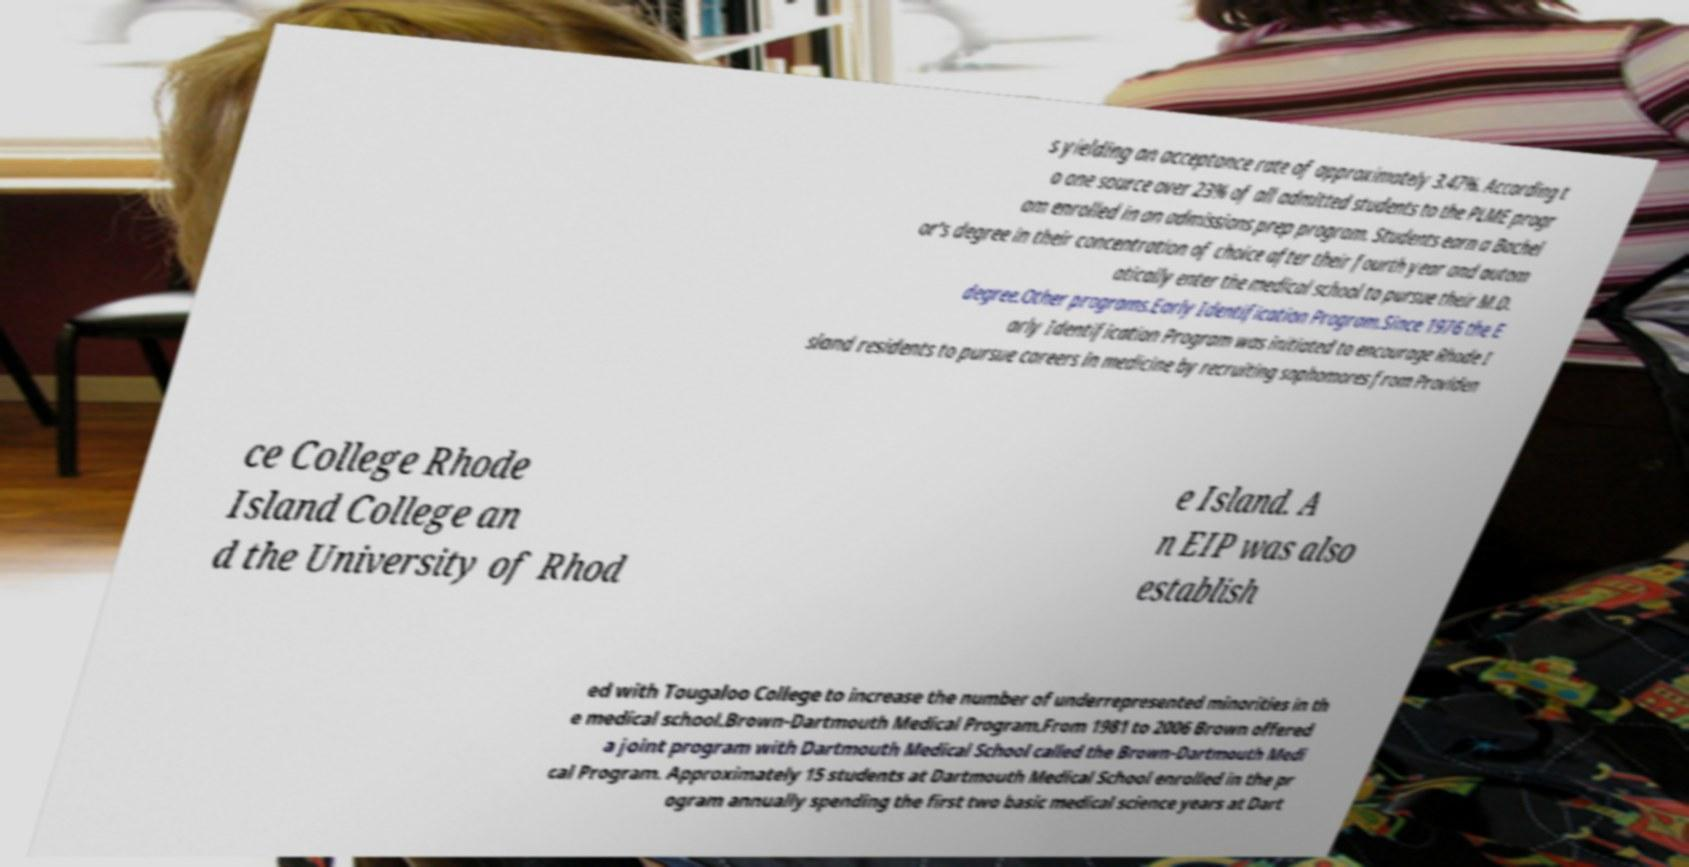Can you accurately transcribe the text from the provided image for me? s yielding an acceptance rate of approximately 3.47%. According t o one source over 23% of all admitted students to the PLME progr am enrolled in an admissions prep program. Students earn a Bachel or's degree in their concentration of choice after their fourth year and autom atically enter the medical school to pursue their M.D. degree.Other programs.Early Identification Program.Since 1976 the E arly Identification Program was initiated to encourage Rhode I sland residents to pursue careers in medicine by recruiting sophomores from Providen ce College Rhode Island College an d the University of Rhod e Island. A n EIP was also establish ed with Tougaloo College to increase the number of underrepresented minorities in th e medical school.Brown-Dartmouth Medical Program.From 1981 to 2006 Brown offered a joint program with Dartmouth Medical School called the Brown-Dartmouth Medi cal Program. Approximately 15 students at Dartmouth Medical School enrolled in the pr ogram annually spending the first two basic medical science years at Dart 